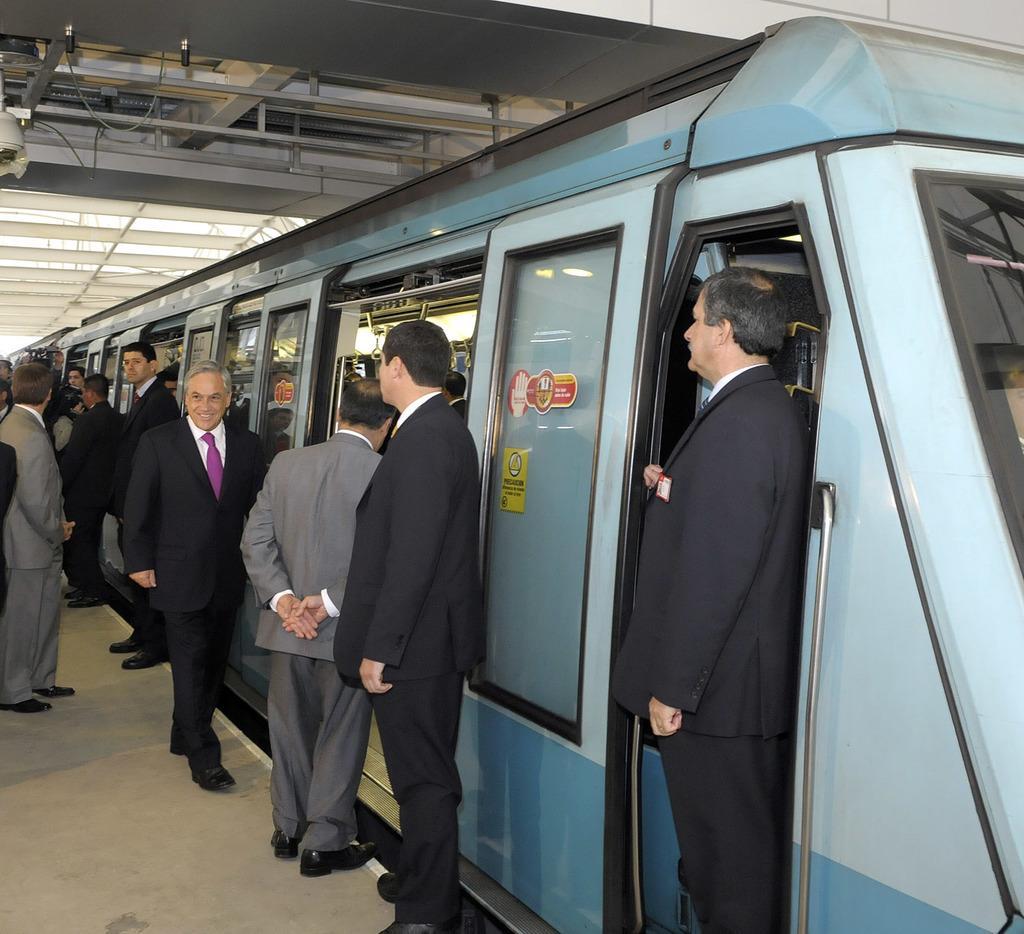Can you describe this image briefly? In this image we can see a train and persons at the railway station. 